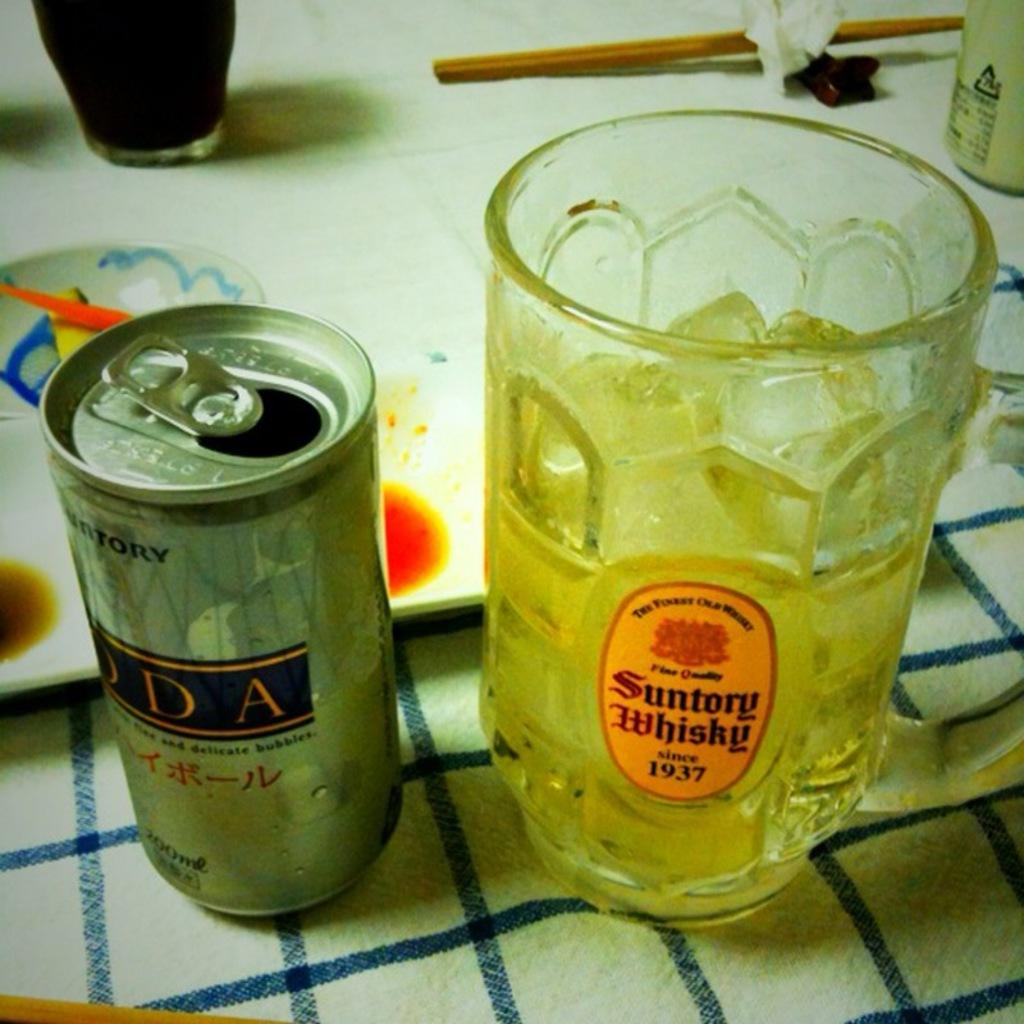What type of tableware can be seen in the image? There are glasses in the image. What other objects are present on the table? There is a tinplate, chopsticks, and a napkin in the image. What might be used for eating in the image? Chopsticks are visible in the image. What can be used for wiping or cleaning in the image? There is a napkin in the image for wiping or cleaning. How do the glasses join together to form a nut in the image? The glasses do not join together to form a nut in the image; they are separate objects. 